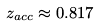<formula> <loc_0><loc_0><loc_500><loc_500>z _ { a c c } \approx 0 . 8 1 7</formula> 